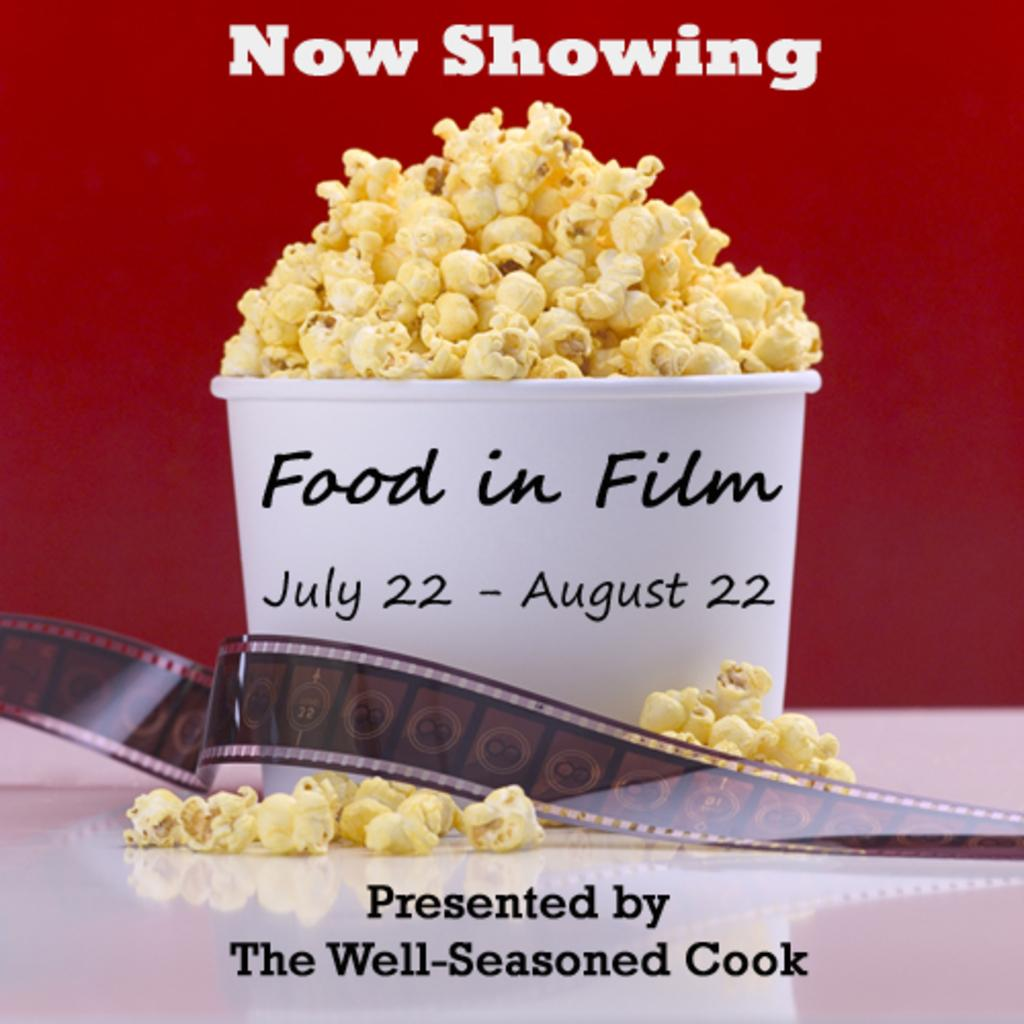What type of container is visible in the image? There is a paper popcorn box in the image. What is inside the popcorn box? The popcorn box is filled with popcorn. What type of polish is being applied to the popcorn in the image? There is no polish being applied to the popcorn in the image; it is simply a container filled with popcorn. 